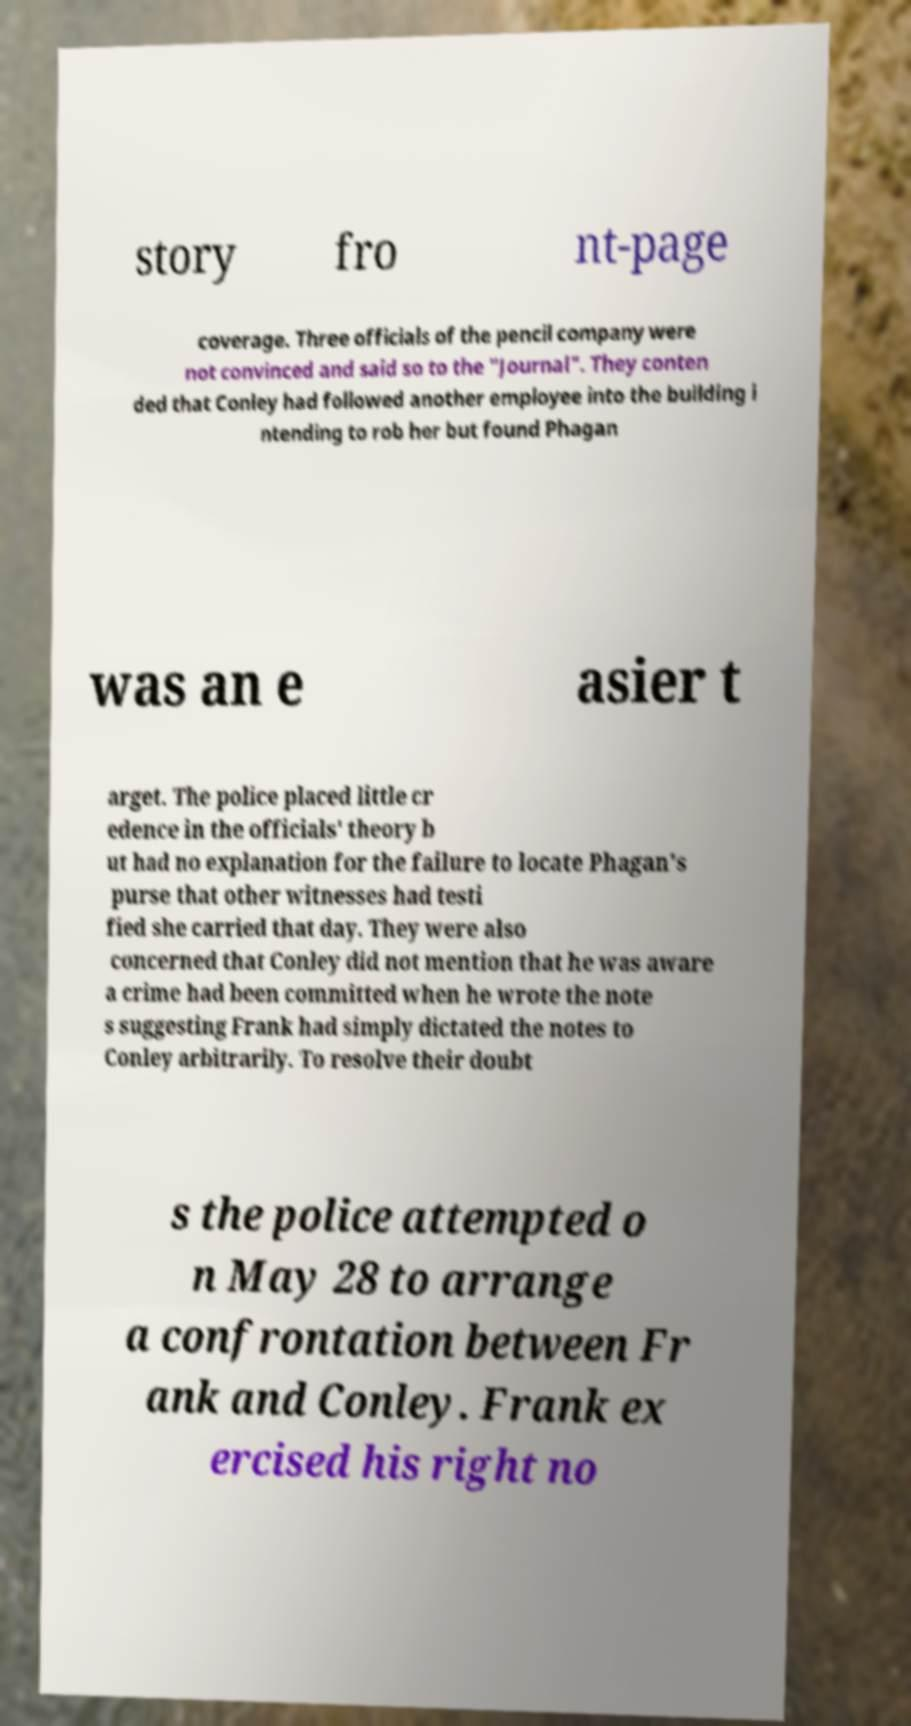Could you assist in decoding the text presented in this image and type it out clearly? story fro nt-page coverage. Three officials of the pencil company were not convinced and said so to the "Journal". They conten ded that Conley had followed another employee into the building i ntending to rob her but found Phagan was an e asier t arget. The police placed little cr edence in the officials' theory b ut had no explanation for the failure to locate Phagan's purse that other witnesses had testi fied she carried that day. They were also concerned that Conley did not mention that he was aware a crime had been committed when he wrote the note s suggesting Frank had simply dictated the notes to Conley arbitrarily. To resolve their doubt s the police attempted o n May 28 to arrange a confrontation between Fr ank and Conley. Frank ex ercised his right no 